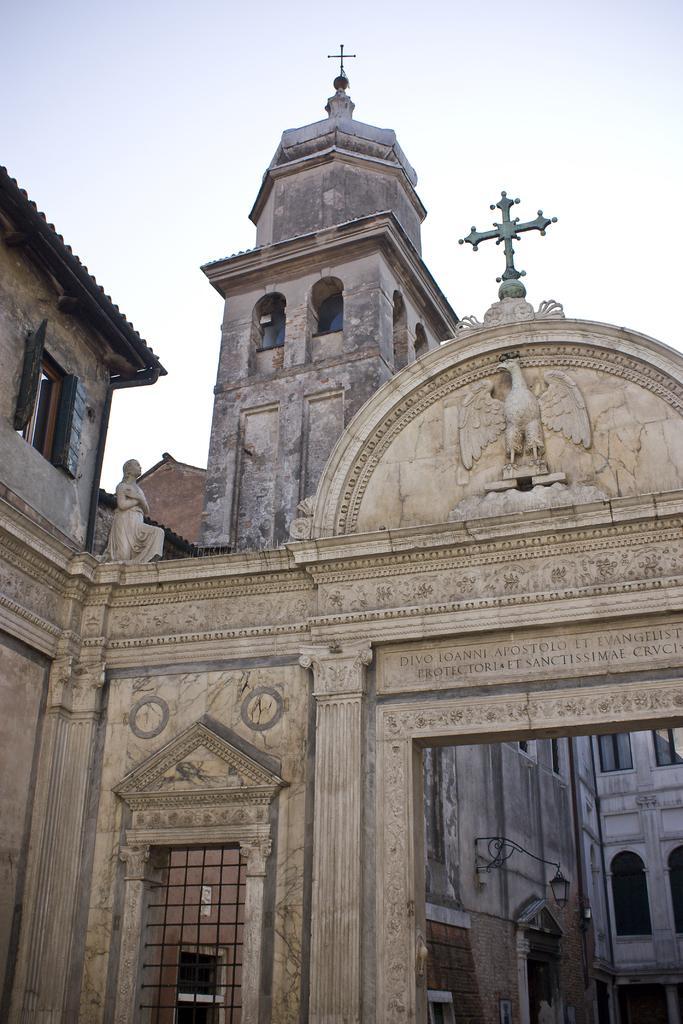Can you describe this image briefly? This is a building and a sky. 